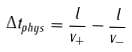Convert formula to latex. <formula><loc_0><loc_0><loc_500><loc_500>\Delta t _ { p h y s } = \frac { l } { v _ { + } } - \frac { l } { v _ { - } }</formula> 